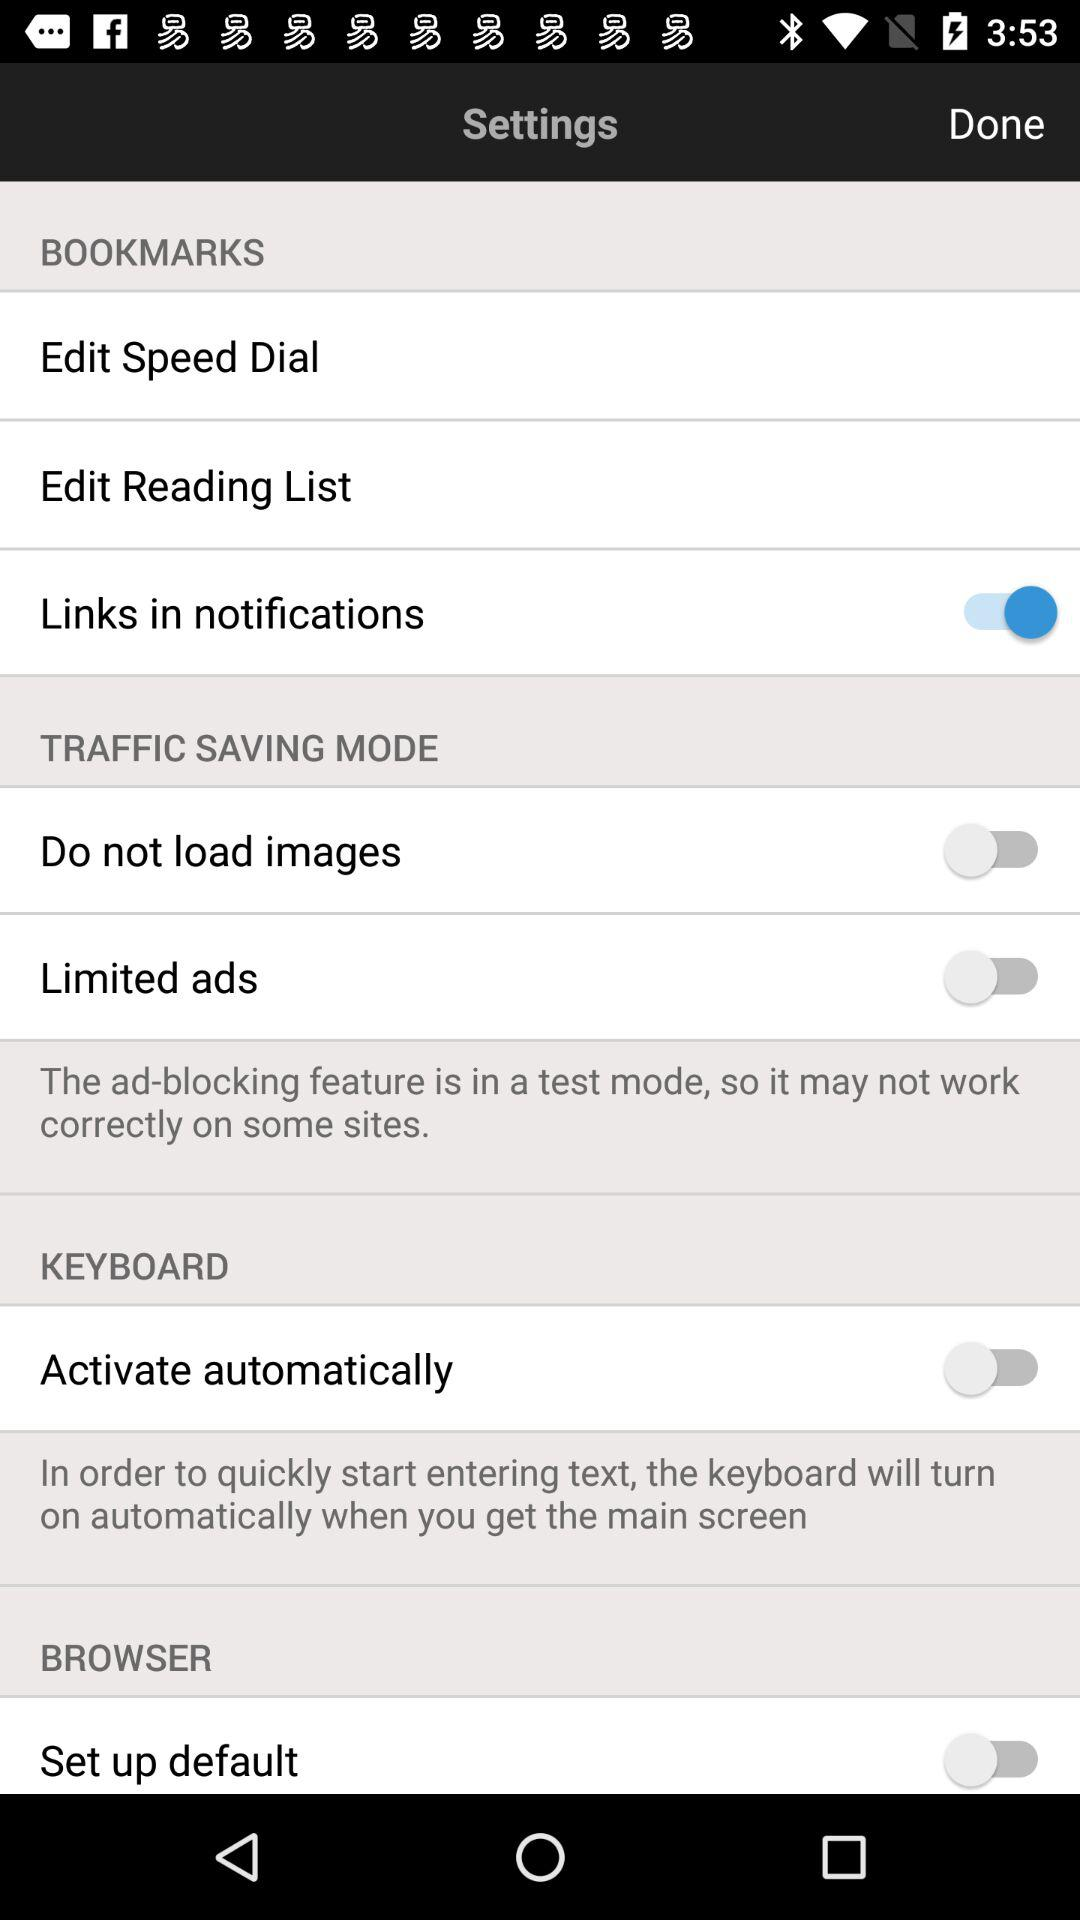How many items are in the bookmarks section?
Answer the question using a single word or phrase. 3 